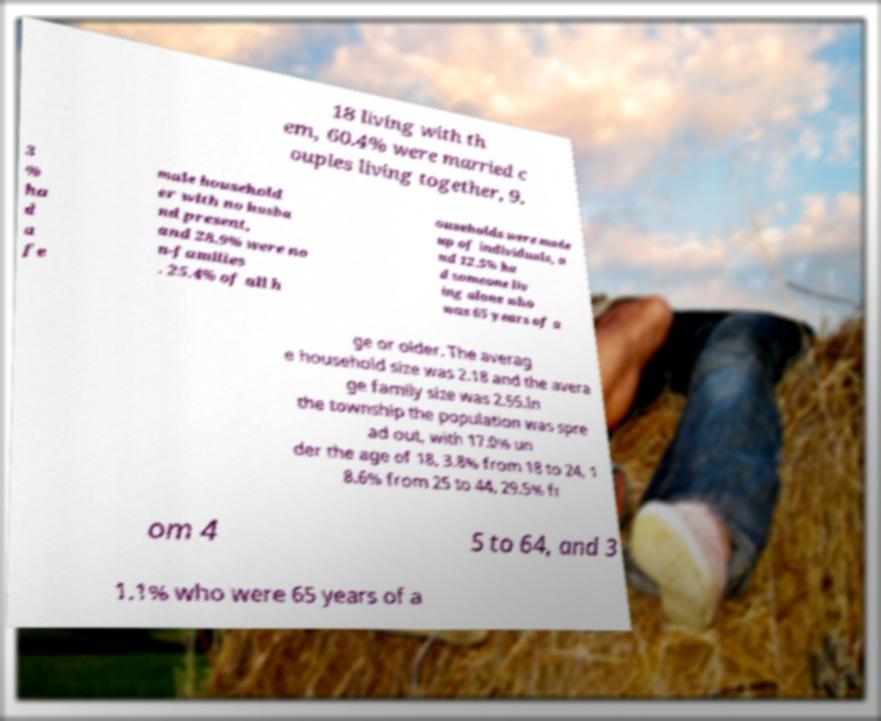Can you accurately transcribe the text from the provided image for me? 18 living with th em, 60.4% were married c ouples living together, 9. 3 % ha d a fe male household er with no husba nd present, and 28.9% were no n-families . 25.4% of all h ouseholds were made up of individuals, a nd 12.5% ha d someone liv ing alone who was 65 years of a ge or older. The averag e household size was 2.18 and the avera ge family size was 2.55.In the township the population was spre ad out, with 17.0% un der the age of 18, 3.8% from 18 to 24, 1 8.6% from 25 to 44, 29.5% fr om 4 5 to 64, and 3 1.1% who were 65 years of a 